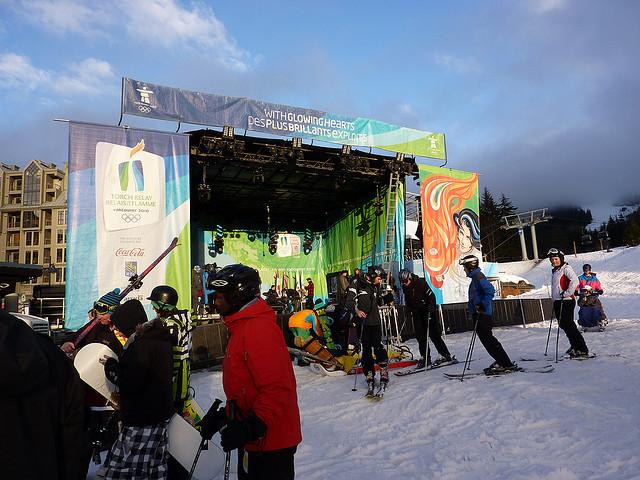Are there clouds in the sky?
Write a very short answer. Yes. Is it a sunny day?
Keep it brief. Yes. Does this look like an event?
Be succinct. Yes. 